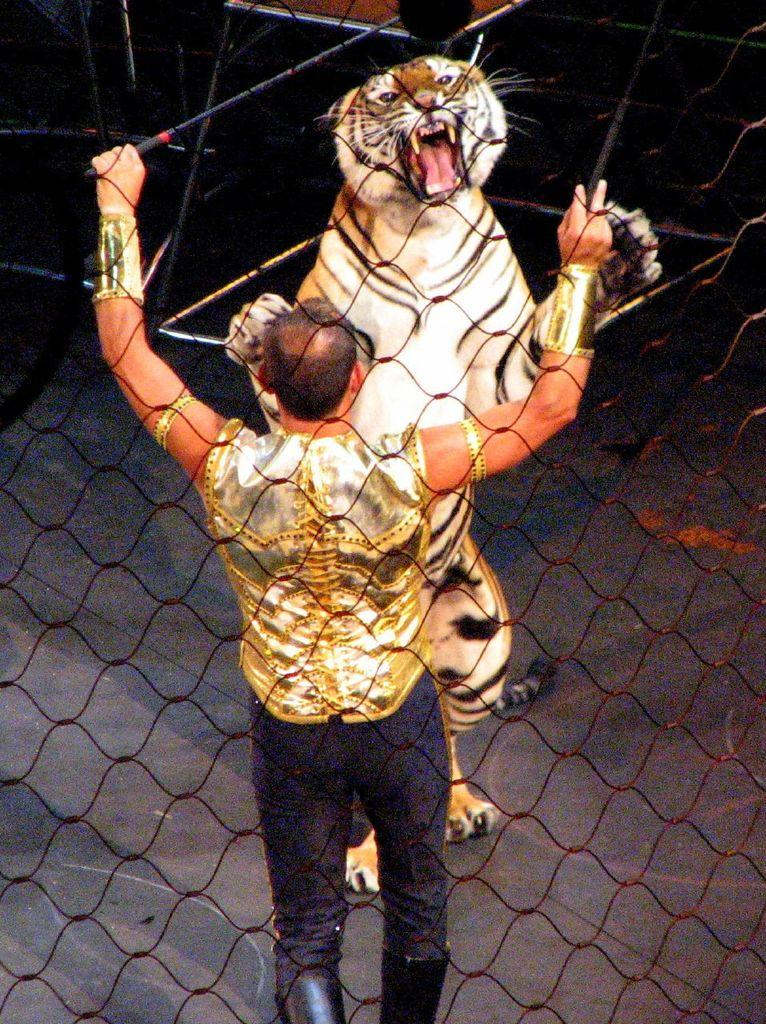What type of fence is present in the image? There is a black color fence in the image. Who or what is standing in the image? There is a man and a tiger standing in the image. What is the tiger doing in the image? The tiger is holding the fence in the image. What type of crime is being committed by the goat in the image? There is no goat present in the image, so no crime can be committed by a goat. What kind of band is playing music in the background of the image? There is no band or music present in the image, so it cannot be determined if a band is playing music in the background. 